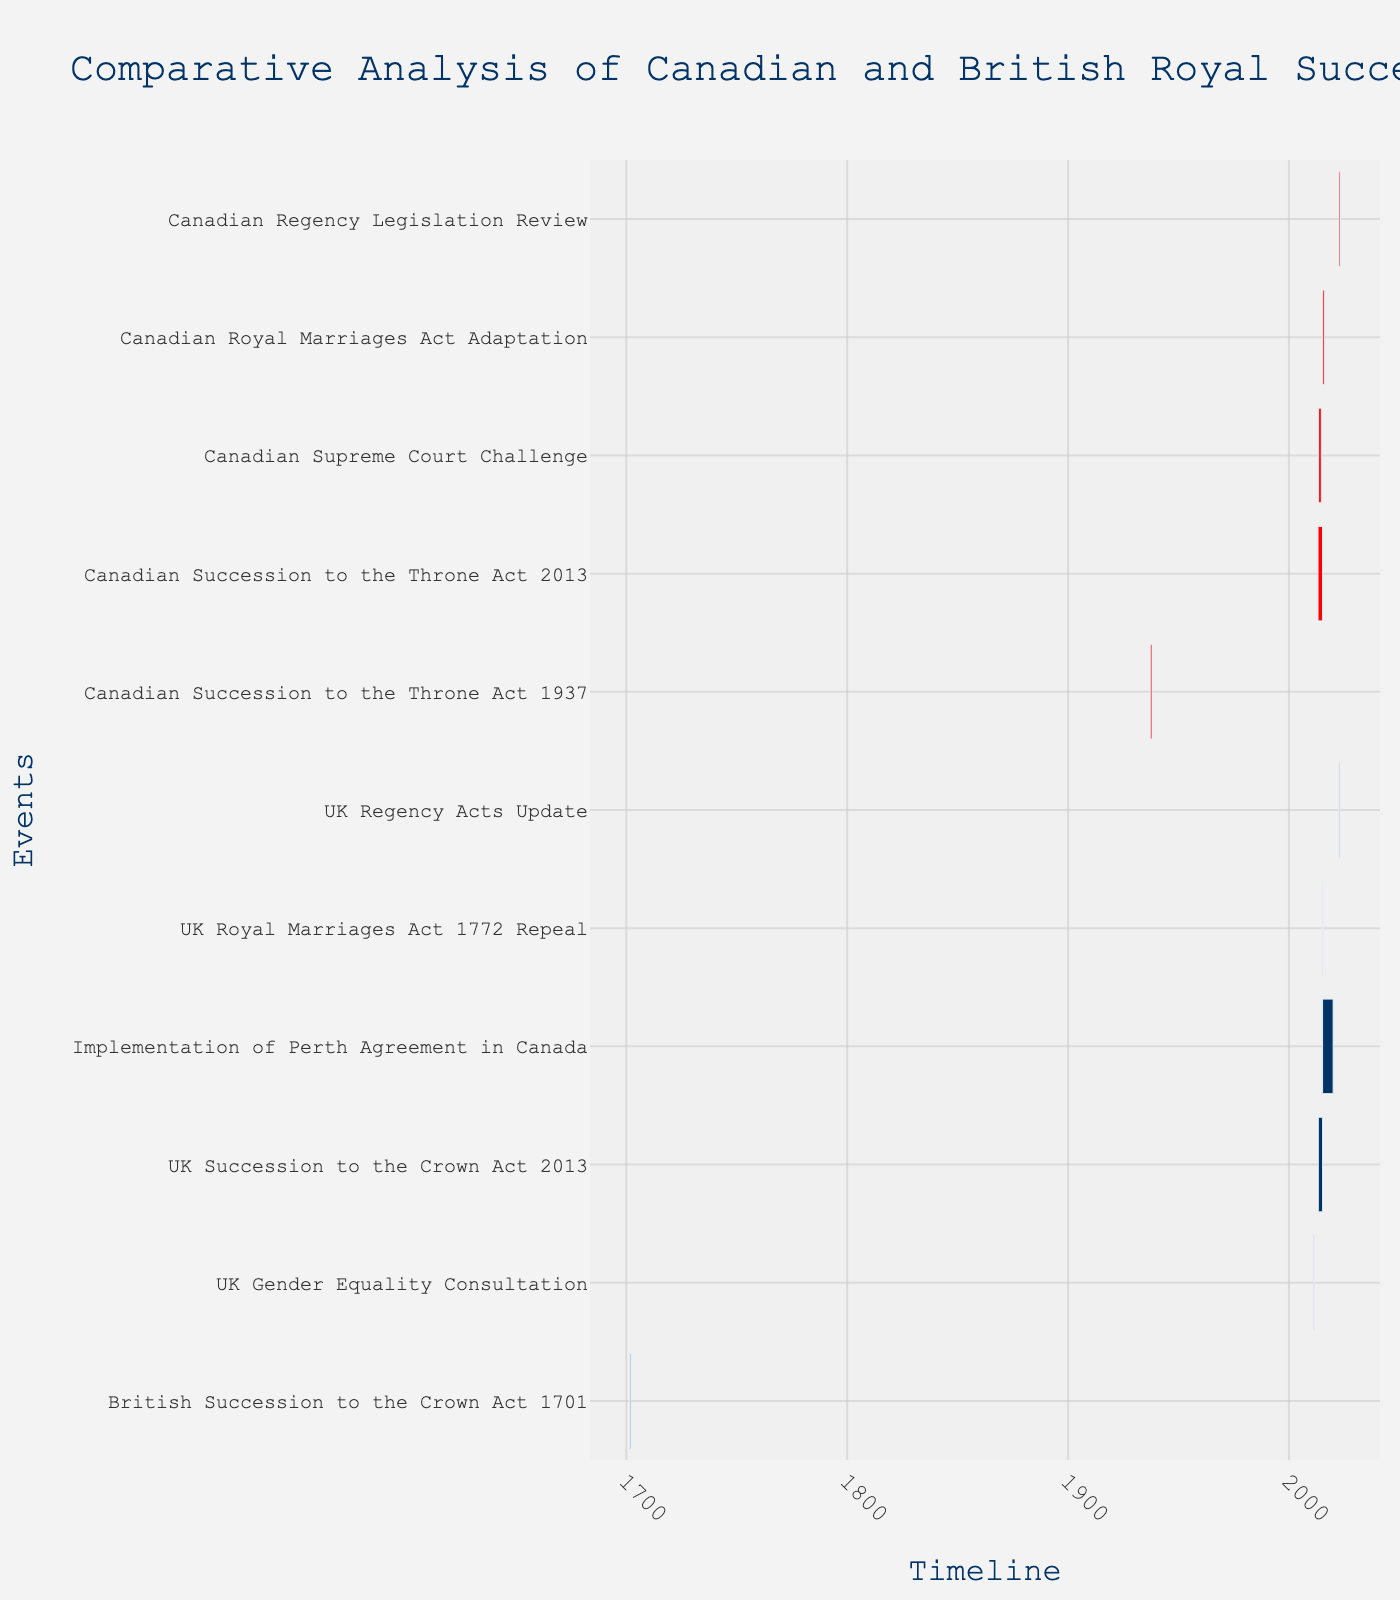What is the title of the chart? The title of the chart is prominently displayed at the top of the figure.
Answer: Comparative Analysis of Canadian and British Royal Succession Laws Which task had the longest duration? To find the task with the longest duration, identify the bar that spans the most time on the horizontal timeline.
Answer: Implementation of Perth Agreement in Canada Which tasks had their implementation periods starting on the same day? Look for tasks that have the same start date on the horizontal axis.
Answer: UK Succession to the Crown Act 2013 and Canadian Succession to the Throne Act 2013 What are the colors representing Canadian tasks in the Gantt chart? The color legend or the description outlines colors used in the chart. All tasks labeled as 'Canadian' share the same color.
Answer: Red How many tasks are related to UK royal succession laws? Count the number of tasks that include 'UK' or 'British' in their description.
Answer: 5 Which tasks had overlapping implementation periods with the UK Succession to the Crown Act 2013? Compare the dates of the UK Succession to the Crown Act 2013 with other tasks to identify overlaps.
Answer: Canadian Succession to the Throne Act 2013 What was the duration of the Canadian Supreme Court Challenge task? Calculate the difference between the start and end dates of the specified task.
Answer: 13 months and 22 days Which country started more tasks related to royal succession laws in 2013? By examining the tasks initiated in 2013, count the tasks for each country.
Answer: Canada Which task concluded last in 2023? The last date on the timeline shows when each task ends. Identify the task with the latest end date.
Answer: Canadian Regency Legislation Review 